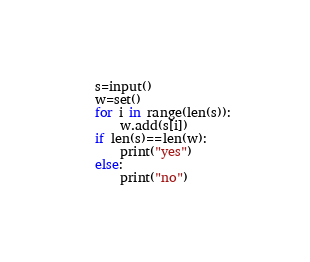<code> <loc_0><loc_0><loc_500><loc_500><_Python_>s=input()
w=set()
for i in range(len(s)):
    w.add(s[i])
if len(s)==len(w):
    print("yes")
else:
    print("no")</code> 